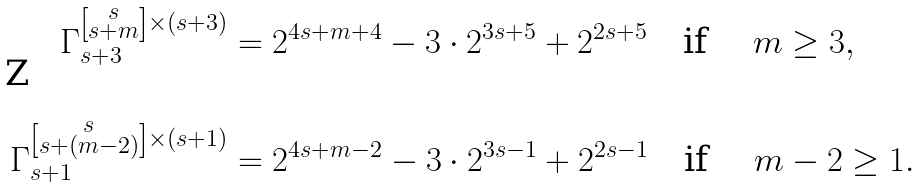Convert formula to latex. <formula><loc_0><loc_0><loc_500><loc_500>\Gamma _ { s + 3 } ^ { \left [ \substack { s \\ s + m } \right ] \times ( s + 3 ) } & = 2 ^ { 4 s + m + 4 } - 3 \cdot 2 ^ { 3 s + 5 } + 2 ^ { 2 s + 5 } \quad \text {if \quad $ m\geq 3 $} , \\ & \\ \Gamma _ { s + 1 } ^ { \left [ \substack { s \\ s + ( m - 2 ) } \right ] \times ( s + 1 ) } & = 2 ^ { 4 s + m - 2 } - 3 \cdot 2 ^ { 3 s - 1 } + 2 ^ { 2 s - 1 } \quad \text {if \quad $ m -2 \geq 1 $} . \\ &</formula> 